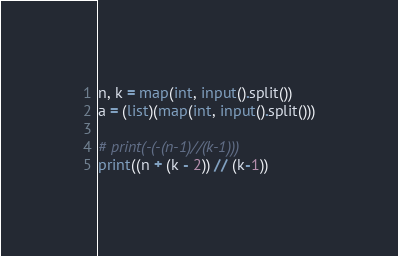<code> <loc_0><loc_0><loc_500><loc_500><_Python_>n, k = map(int, input().split())
a = (list)(map(int, input().split()))

# print(-(-(n-1)//(k-1)))
print((n + (k - 2)) // (k-1))
</code> 